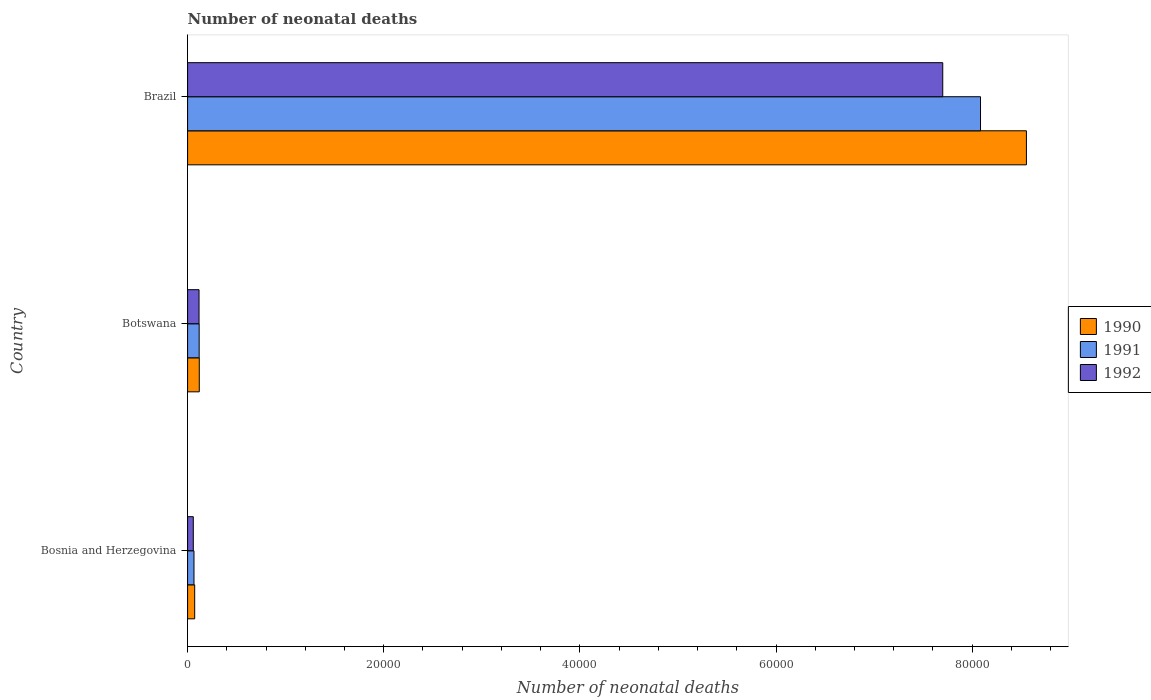How many different coloured bars are there?
Provide a succinct answer. 3. How many bars are there on the 3rd tick from the bottom?
Offer a terse response. 3. What is the label of the 3rd group of bars from the top?
Your response must be concise. Bosnia and Herzegovina. In how many cases, is the number of bars for a given country not equal to the number of legend labels?
Your answer should be compact. 0. What is the number of neonatal deaths in in 1992 in Brazil?
Ensure brevity in your answer.  7.70e+04. Across all countries, what is the maximum number of neonatal deaths in in 1990?
Offer a terse response. 8.55e+04. Across all countries, what is the minimum number of neonatal deaths in in 1990?
Make the answer very short. 723. In which country was the number of neonatal deaths in in 1992 minimum?
Make the answer very short. Bosnia and Herzegovina. What is the total number of neonatal deaths in in 1992 in the graph?
Offer a very short reply. 7.88e+04. What is the difference between the number of neonatal deaths in in 1990 in Bosnia and Herzegovina and that in Botswana?
Your answer should be compact. -468. What is the difference between the number of neonatal deaths in in 1992 in Bosnia and Herzegovina and the number of neonatal deaths in in 1990 in Brazil?
Your answer should be compact. -8.50e+04. What is the average number of neonatal deaths in in 1992 per country?
Offer a terse response. 2.62e+04. What is the difference between the number of neonatal deaths in in 1991 and number of neonatal deaths in in 1990 in Botswana?
Offer a terse response. -11. What is the ratio of the number of neonatal deaths in in 1990 in Bosnia and Herzegovina to that in Brazil?
Offer a terse response. 0.01. Is the number of neonatal deaths in in 1992 in Bosnia and Herzegovina less than that in Brazil?
Offer a very short reply. Yes. What is the difference between the highest and the second highest number of neonatal deaths in in 1991?
Provide a short and direct response. 7.97e+04. What is the difference between the highest and the lowest number of neonatal deaths in in 1991?
Provide a succinct answer. 8.02e+04. What does the 2nd bar from the top in Bosnia and Herzegovina represents?
Offer a terse response. 1991. What does the 2nd bar from the bottom in Brazil represents?
Ensure brevity in your answer.  1991. Is it the case that in every country, the sum of the number of neonatal deaths in in 1991 and number of neonatal deaths in in 1990 is greater than the number of neonatal deaths in in 1992?
Keep it short and to the point. Yes. Are all the bars in the graph horizontal?
Keep it short and to the point. Yes. How many countries are there in the graph?
Give a very brief answer. 3. Does the graph contain any zero values?
Offer a very short reply. No. Does the graph contain grids?
Your response must be concise. No. How are the legend labels stacked?
Give a very brief answer. Vertical. What is the title of the graph?
Provide a succinct answer. Number of neonatal deaths. What is the label or title of the X-axis?
Offer a terse response. Number of neonatal deaths. What is the Number of neonatal deaths in 1990 in Bosnia and Herzegovina?
Give a very brief answer. 723. What is the Number of neonatal deaths of 1991 in Bosnia and Herzegovina?
Provide a short and direct response. 652. What is the Number of neonatal deaths of 1992 in Bosnia and Herzegovina?
Your answer should be very brief. 581. What is the Number of neonatal deaths of 1990 in Botswana?
Ensure brevity in your answer.  1191. What is the Number of neonatal deaths of 1991 in Botswana?
Give a very brief answer. 1180. What is the Number of neonatal deaths in 1992 in Botswana?
Offer a terse response. 1167. What is the Number of neonatal deaths in 1990 in Brazil?
Ensure brevity in your answer.  8.55e+04. What is the Number of neonatal deaths of 1991 in Brazil?
Offer a terse response. 8.09e+04. What is the Number of neonatal deaths of 1992 in Brazil?
Keep it short and to the point. 7.70e+04. Across all countries, what is the maximum Number of neonatal deaths in 1990?
Ensure brevity in your answer.  8.55e+04. Across all countries, what is the maximum Number of neonatal deaths of 1991?
Your answer should be compact. 8.09e+04. Across all countries, what is the maximum Number of neonatal deaths of 1992?
Offer a terse response. 7.70e+04. Across all countries, what is the minimum Number of neonatal deaths of 1990?
Your answer should be compact. 723. Across all countries, what is the minimum Number of neonatal deaths in 1991?
Offer a very short reply. 652. Across all countries, what is the minimum Number of neonatal deaths of 1992?
Give a very brief answer. 581. What is the total Number of neonatal deaths of 1990 in the graph?
Your answer should be compact. 8.74e+04. What is the total Number of neonatal deaths in 1991 in the graph?
Ensure brevity in your answer.  8.27e+04. What is the total Number of neonatal deaths in 1992 in the graph?
Your answer should be compact. 7.88e+04. What is the difference between the Number of neonatal deaths of 1990 in Bosnia and Herzegovina and that in Botswana?
Your response must be concise. -468. What is the difference between the Number of neonatal deaths of 1991 in Bosnia and Herzegovina and that in Botswana?
Your response must be concise. -528. What is the difference between the Number of neonatal deaths in 1992 in Bosnia and Herzegovina and that in Botswana?
Provide a succinct answer. -586. What is the difference between the Number of neonatal deaths of 1990 in Bosnia and Herzegovina and that in Brazil?
Ensure brevity in your answer.  -8.48e+04. What is the difference between the Number of neonatal deaths of 1991 in Bosnia and Herzegovina and that in Brazil?
Your answer should be very brief. -8.02e+04. What is the difference between the Number of neonatal deaths in 1992 in Bosnia and Herzegovina and that in Brazil?
Provide a short and direct response. -7.64e+04. What is the difference between the Number of neonatal deaths in 1990 in Botswana and that in Brazil?
Offer a very short reply. -8.43e+04. What is the difference between the Number of neonatal deaths in 1991 in Botswana and that in Brazil?
Ensure brevity in your answer.  -7.97e+04. What is the difference between the Number of neonatal deaths in 1992 in Botswana and that in Brazil?
Make the answer very short. -7.58e+04. What is the difference between the Number of neonatal deaths in 1990 in Bosnia and Herzegovina and the Number of neonatal deaths in 1991 in Botswana?
Ensure brevity in your answer.  -457. What is the difference between the Number of neonatal deaths in 1990 in Bosnia and Herzegovina and the Number of neonatal deaths in 1992 in Botswana?
Make the answer very short. -444. What is the difference between the Number of neonatal deaths of 1991 in Bosnia and Herzegovina and the Number of neonatal deaths of 1992 in Botswana?
Ensure brevity in your answer.  -515. What is the difference between the Number of neonatal deaths of 1990 in Bosnia and Herzegovina and the Number of neonatal deaths of 1991 in Brazil?
Give a very brief answer. -8.01e+04. What is the difference between the Number of neonatal deaths in 1990 in Bosnia and Herzegovina and the Number of neonatal deaths in 1992 in Brazil?
Your response must be concise. -7.63e+04. What is the difference between the Number of neonatal deaths of 1991 in Bosnia and Herzegovina and the Number of neonatal deaths of 1992 in Brazil?
Make the answer very short. -7.64e+04. What is the difference between the Number of neonatal deaths of 1990 in Botswana and the Number of neonatal deaths of 1991 in Brazil?
Keep it short and to the point. -7.97e+04. What is the difference between the Number of neonatal deaths of 1990 in Botswana and the Number of neonatal deaths of 1992 in Brazil?
Offer a very short reply. -7.58e+04. What is the difference between the Number of neonatal deaths in 1991 in Botswana and the Number of neonatal deaths in 1992 in Brazil?
Give a very brief answer. -7.58e+04. What is the average Number of neonatal deaths of 1990 per country?
Make the answer very short. 2.91e+04. What is the average Number of neonatal deaths in 1991 per country?
Keep it short and to the point. 2.76e+04. What is the average Number of neonatal deaths of 1992 per country?
Give a very brief answer. 2.62e+04. What is the difference between the Number of neonatal deaths in 1990 and Number of neonatal deaths in 1991 in Bosnia and Herzegovina?
Make the answer very short. 71. What is the difference between the Number of neonatal deaths of 1990 and Number of neonatal deaths of 1992 in Bosnia and Herzegovina?
Ensure brevity in your answer.  142. What is the difference between the Number of neonatal deaths of 1991 and Number of neonatal deaths of 1992 in Bosnia and Herzegovina?
Give a very brief answer. 71. What is the difference between the Number of neonatal deaths in 1990 and Number of neonatal deaths in 1991 in Botswana?
Provide a short and direct response. 11. What is the difference between the Number of neonatal deaths of 1990 and Number of neonatal deaths of 1992 in Botswana?
Offer a terse response. 24. What is the difference between the Number of neonatal deaths of 1990 and Number of neonatal deaths of 1991 in Brazil?
Keep it short and to the point. 4682. What is the difference between the Number of neonatal deaths in 1990 and Number of neonatal deaths in 1992 in Brazil?
Provide a short and direct response. 8532. What is the difference between the Number of neonatal deaths in 1991 and Number of neonatal deaths in 1992 in Brazil?
Give a very brief answer. 3850. What is the ratio of the Number of neonatal deaths of 1990 in Bosnia and Herzegovina to that in Botswana?
Your response must be concise. 0.61. What is the ratio of the Number of neonatal deaths in 1991 in Bosnia and Herzegovina to that in Botswana?
Give a very brief answer. 0.55. What is the ratio of the Number of neonatal deaths of 1992 in Bosnia and Herzegovina to that in Botswana?
Give a very brief answer. 0.5. What is the ratio of the Number of neonatal deaths of 1990 in Bosnia and Herzegovina to that in Brazil?
Your answer should be compact. 0.01. What is the ratio of the Number of neonatal deaths of 1991 in Bosnia and Herzegovina to that in Brazil?
Your response must be concise. 0.01. What is the ratio of the Number of neonatal deaths of 1992 in Bosnia and Herzegovina to that in Brazil?
Your answer should be very brief. 0.01. What is the ratio of the Number of neonatal deaths of 1990 in Botswana to that in Brazil?
Your answer should be compact. 0.01. What is the ratio of the Number of neonatal deaths in 1991 in Botswana to that in Brazil?
Make the answer very short. 0.01. What is the ratio of the Number of neonatal deaths in 1992 in Botswana to that in Brazil?
Give a very brief answer. 0.02. What is the difference between the highest and the second highest Number of neonatal deaths in 1990?
Offer a very short reply. 8.43e+04. What is the difference between the highest and the second highest Number of neonatal deaths of 1991?
Offer a terse response. 7.97e+04. What is the difference between the highest and the second highest Number of neonatal deaths in 1992?
Keep it short and to the point. 7.58e+04. What is the difference between the highest and the lowest Number of neonatal deaths in 1990?
Give a very brief answer. 8.48e+04. What is the difference between the highest and the lowest Number of neonatal deaths of 1991?
Provide a short and direct response. 8.02e+04. What is the difference between the highest and the lowest Number of neonatal deaths of 1992?
Ensure brevity in your answer.  7.64e+04. 